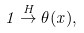<formula> <loc_0><loc_0><loc_500><loc_500>1 \stackrel { H } { \rightarrow } \theta ( x ) ,</formula> 